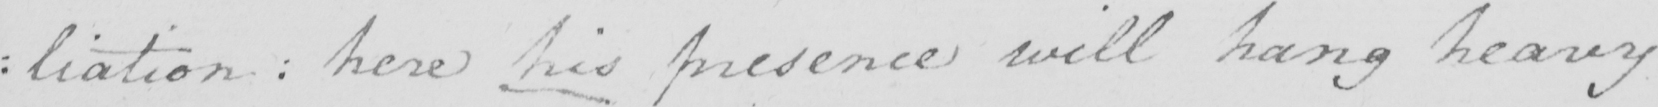What text is written in this handwritten line? : liation :  here his presence will hang heavy 